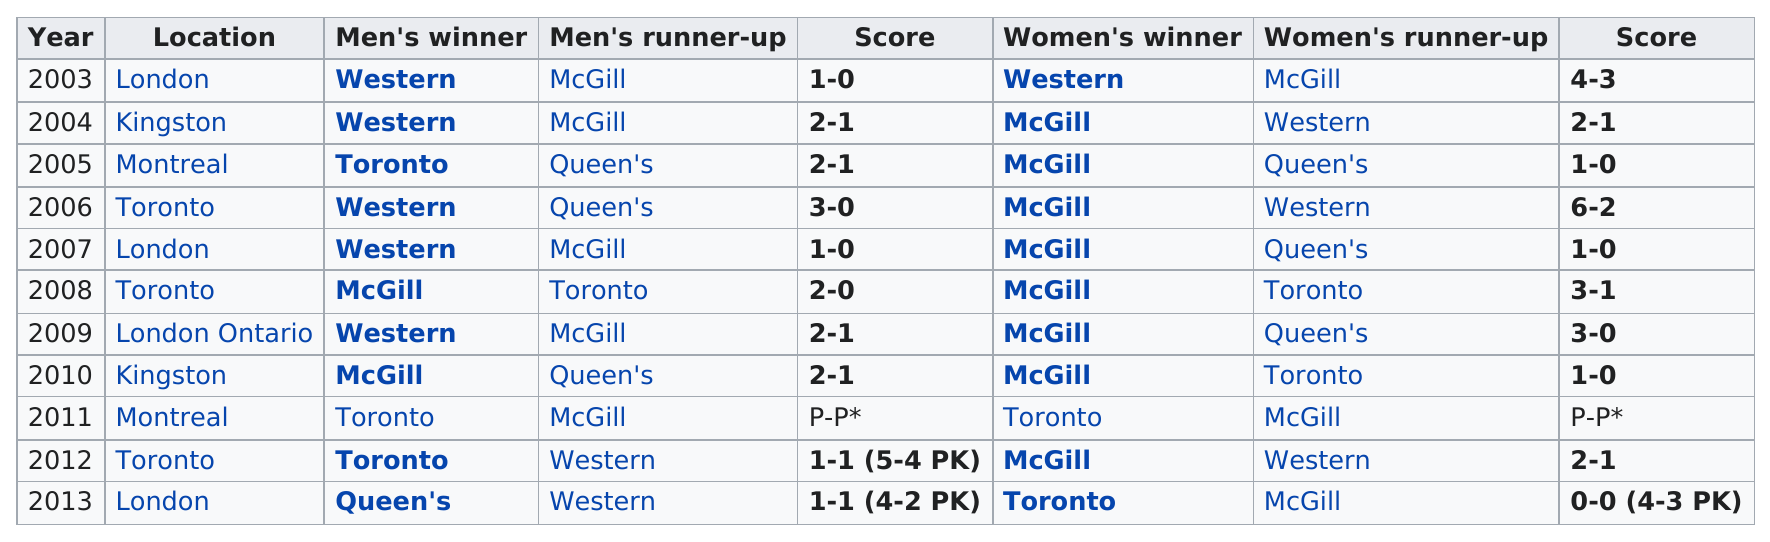Outline some significant characteristics in this image. The team that won the least number of final matches between 2003 and 2013 was Toronto. Western was the top winner in the women's tournament in 2003. The location in Montreal was visited a total of 2 times. After the Western men's hockey team won in 2007, the next team to win the men's game was McGill. Western team won the most games in London after 2005. 